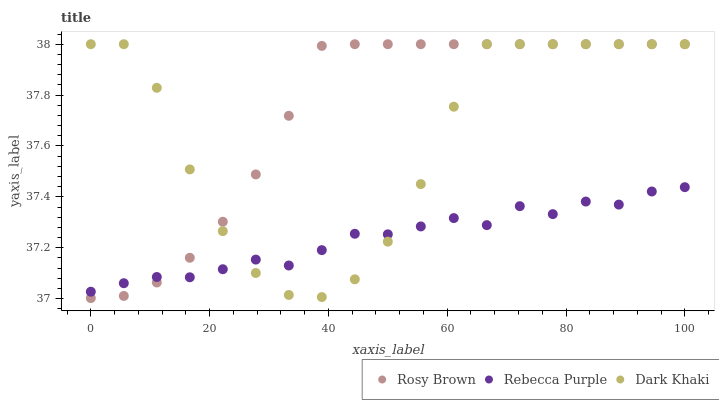Does Rebecca Purple have the minimum area under the curve?
Answer yes or no. Yes. Does Rosy Brown have the maximum area under the curve?
Answer yes or no. Yes. Does Rosy Brown have the minimum area under the curve?
Answer yes or no. No. Does Rebecca Purple have the maximum area under the curve?
Answer yes or no. No. Is Rosy Brown the smoothest?
Answer yes or no. Yes. Is Dark Khaki the roughest?
Answer yes or no. Yes. Is Rebecca Purple the smoothest?
Answer yes or no. No. Is Rebecca Purple the roughest?
Answer yes or no. No. Does Rosy Brown have the lowest value?
Answer yes or no. Yes. Does Rebecca Purple have the lowest value?
Answer yes or no. No. Does Rosy Brown have the highest value?
Answer yes or no. Yes. Does Rebecca Purple have the highest value?
Answer yes or no. No. Does Dark Khaki intersect Rosy Brown?
Answer yes or no. Yes. Is Dark Khaki less than Rosy Brown?
Answer yes or no. No. Is Dark Khaki greater than Rosy Brown?
Answer yes or no. No. 